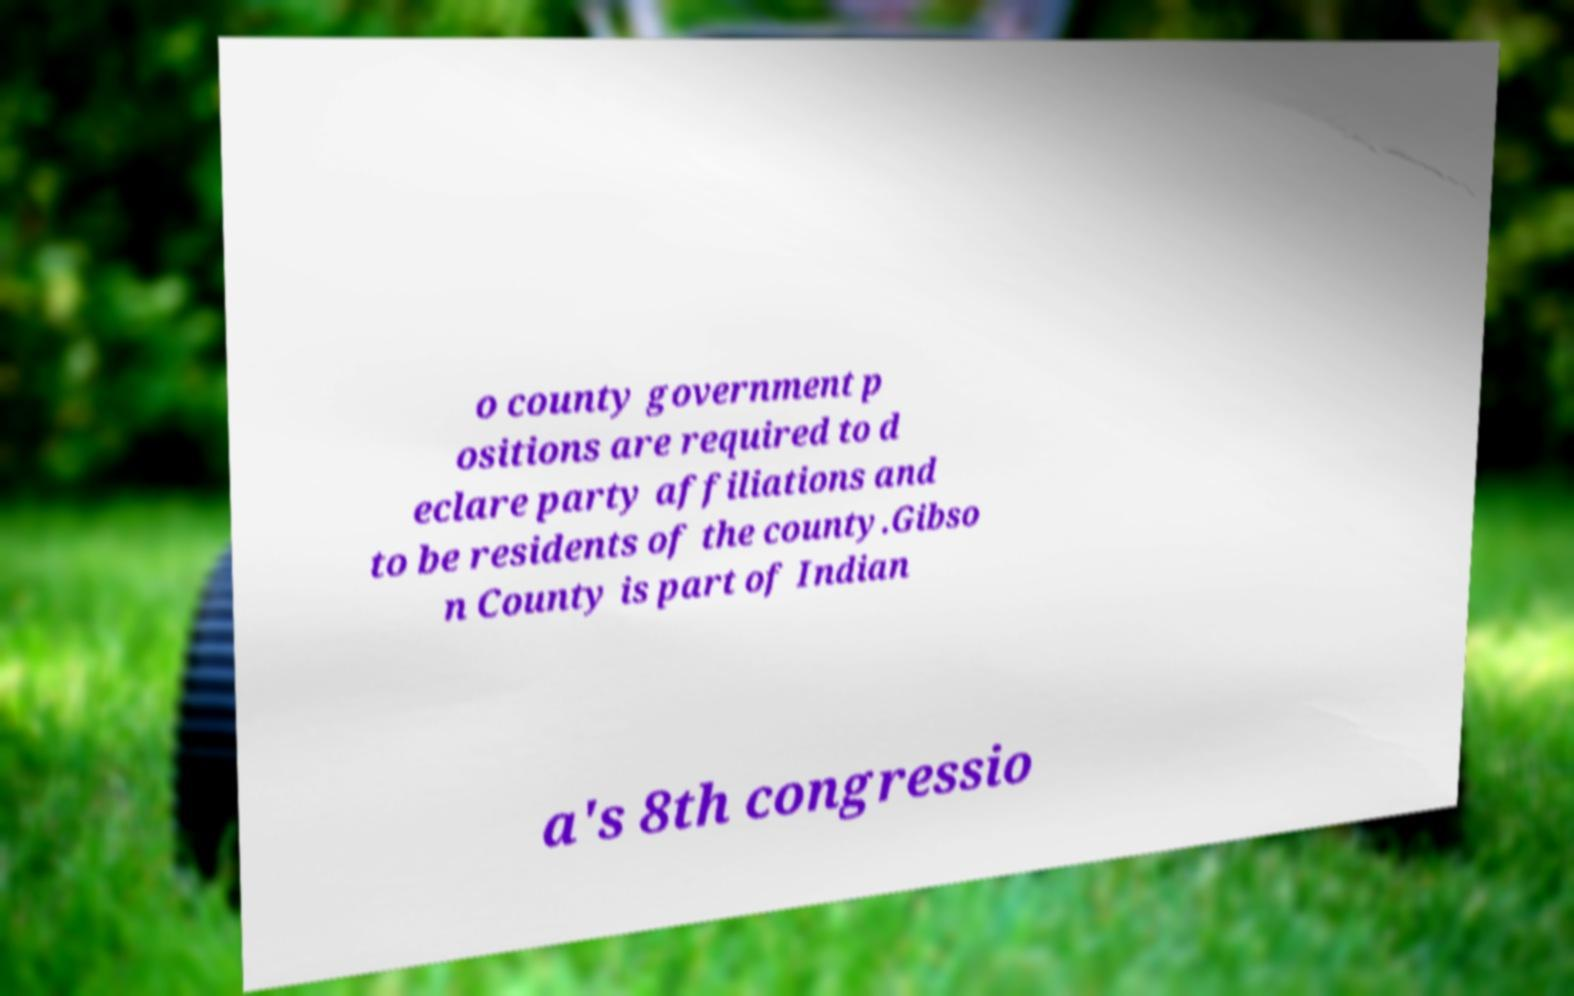For documentation purposes, I need the text within this image transcribed. Could you provide that? o county government p ositions are required to d eclare party affiliations and to be residents of the county.Gibso n County is part of Indian a's 8th congressio 